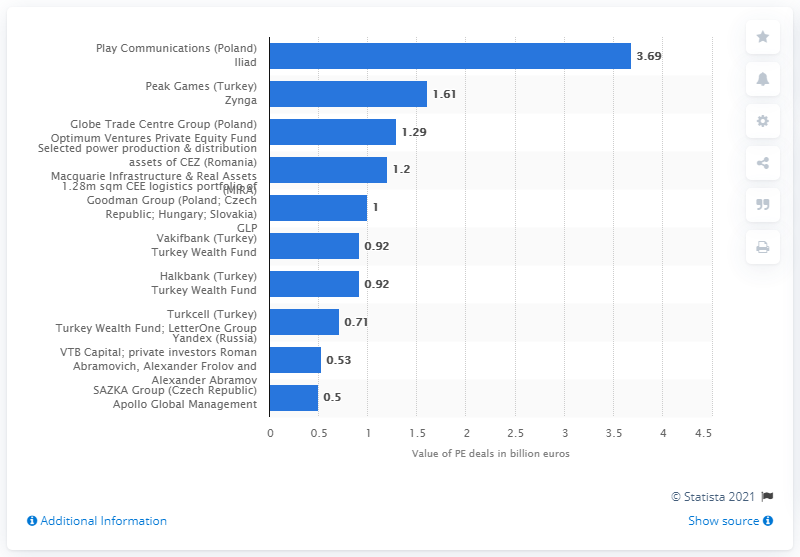Mention a couple of crucial points in this snapshot. The second largest PE deal in Central and Eastern Europe had a value of 1.61... The largest private equity deal in Central and Eastern Europe was worth 3.69... 